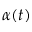<formula> <loc_0><loc_0><loc_500><loc_500>\alpha ( t )</formula> 